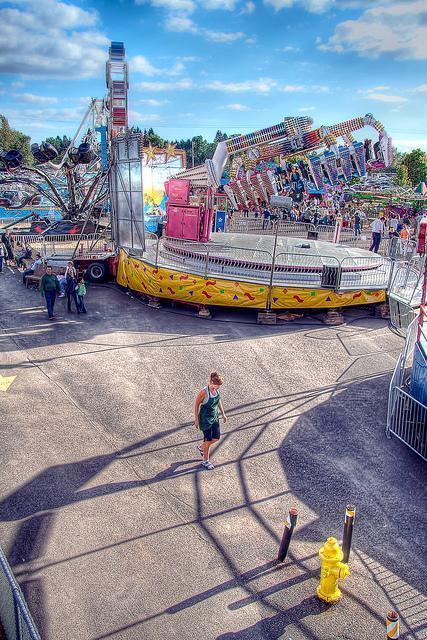How many sheep are there?
Give a very brief answer. 0. 